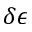Convert formula to latex. <formula><loc_0><loc_0><loc_500><loc_500>\delta \epsilon</formula> 